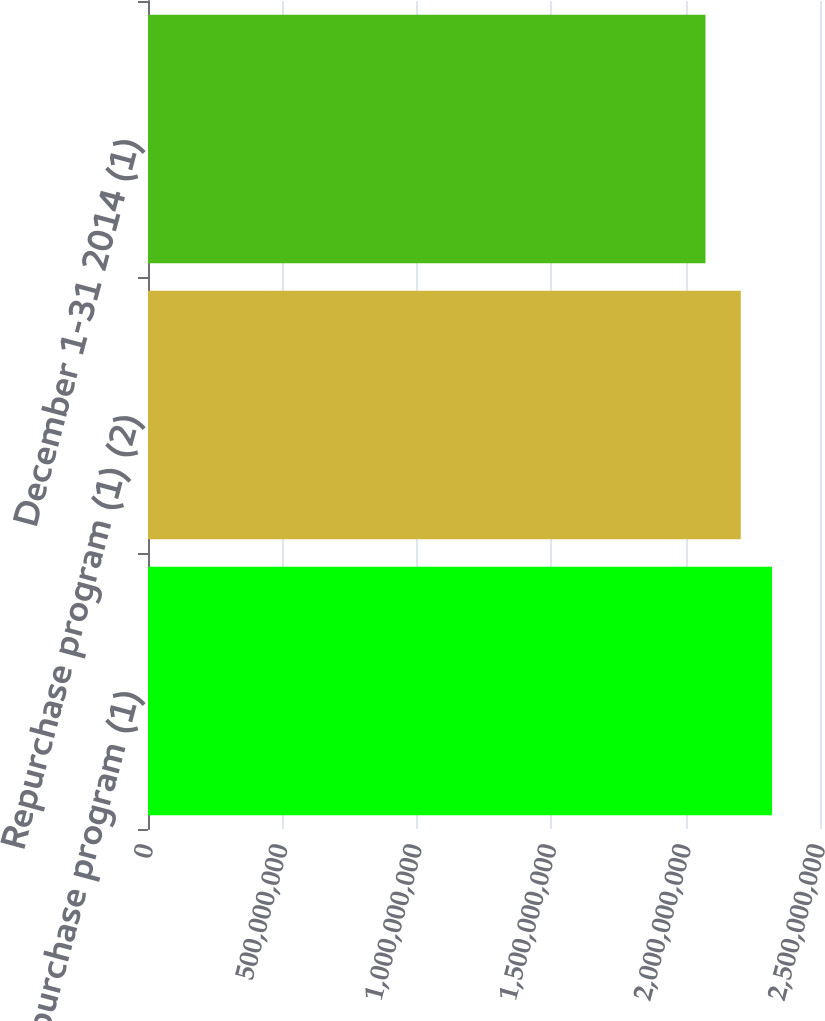Convert chart. <chart><loc_0><loc_0><loc_500><loc_500><bar_chart><fcel>Repurchase program (1)<fcel>Repurchase program (1) (2)<fcel>December 1-31 2014 (1)<nl><fcel>2.32159e+09<fcel>2.20532e+09<fcel>2.0741e+09<nl></chart> 